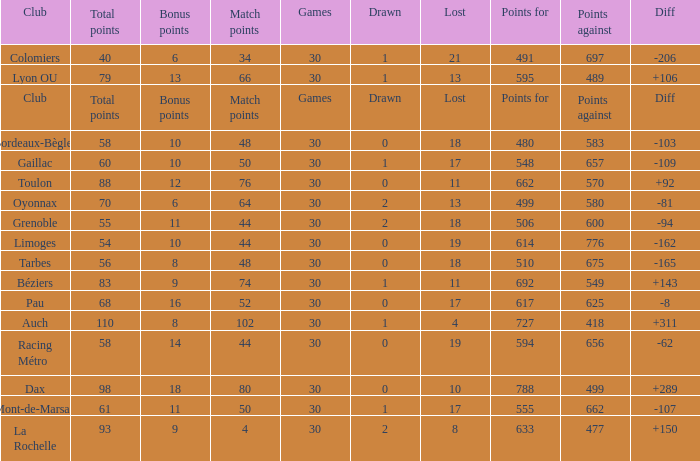What is the value of match points when the points for is 570? 76.0. 